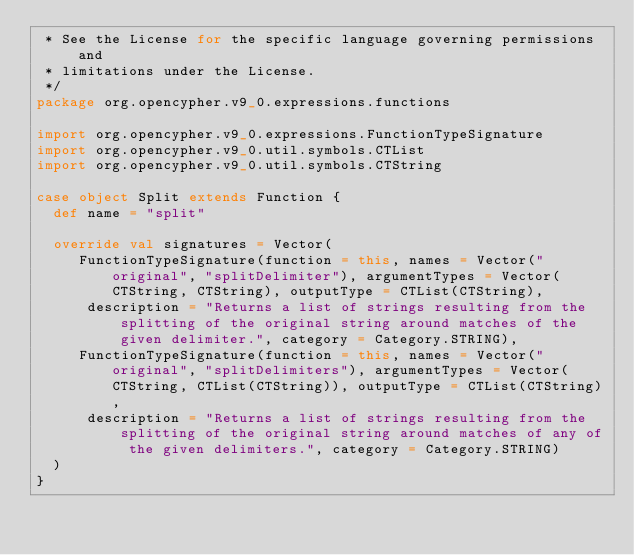Convert code to text. <code><loc_0><loc_0><loc_500><loc_500><_Scala_> * See the License for the specific language governing permissions and
 * limitations under the License.
 */
package org.opencypher.v9_0.expressions.functions

import org.opencypher.v9_0.expressions.FunctionTypeSignature
import org.opencypher.v9_0.util.symbols.CTList
import org.opencypher.v9_0.util.symbols.CTString

case object Split extends Function {
  def name = "split"

  override val signatures = Vector(
     FunctionTypeSignature(function = this, names = Vector("original", "splitDelimiter"), argumentTypes = Vector(CTString, CTString), outputType = CTList(CTString),
      description = "Returns a list of strings resulting from the splitting of the original string around matches of the given delimiter.", category = Category.STRING),
     FunctionTypeSignature(function = this, names = Vector("original", "splitDelimiters"), argumentTypes = Vector(CTString, CTList(CTString)), outputType = CTList(CTString),
      description = "Returns a list of strings resulting from the splitting of the original string around matches of any of the given delimiters.", category = Category.STRING)
  )
}
</code> 